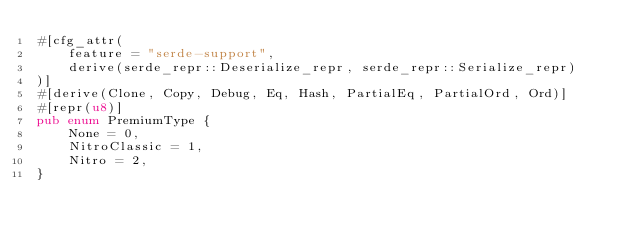Convert code to text. <code><loc_0><loc_0><loc_500><loc_500><_Rust_>#[cfg_attr(
    feature = "serde-support",
    derive(serde_repr::Deserialize_repr, serde_repr::Serialize_repr)
)]
#[derive(Clone, Copy, Debug, Eq, Hash, PartialEq, PartialOrd, Ord)]
#[repr(u8)]
pub enum PremiumType {
    None = 0,
    NitroClassic = 1,
    Nitro = 2,
}
</code> 